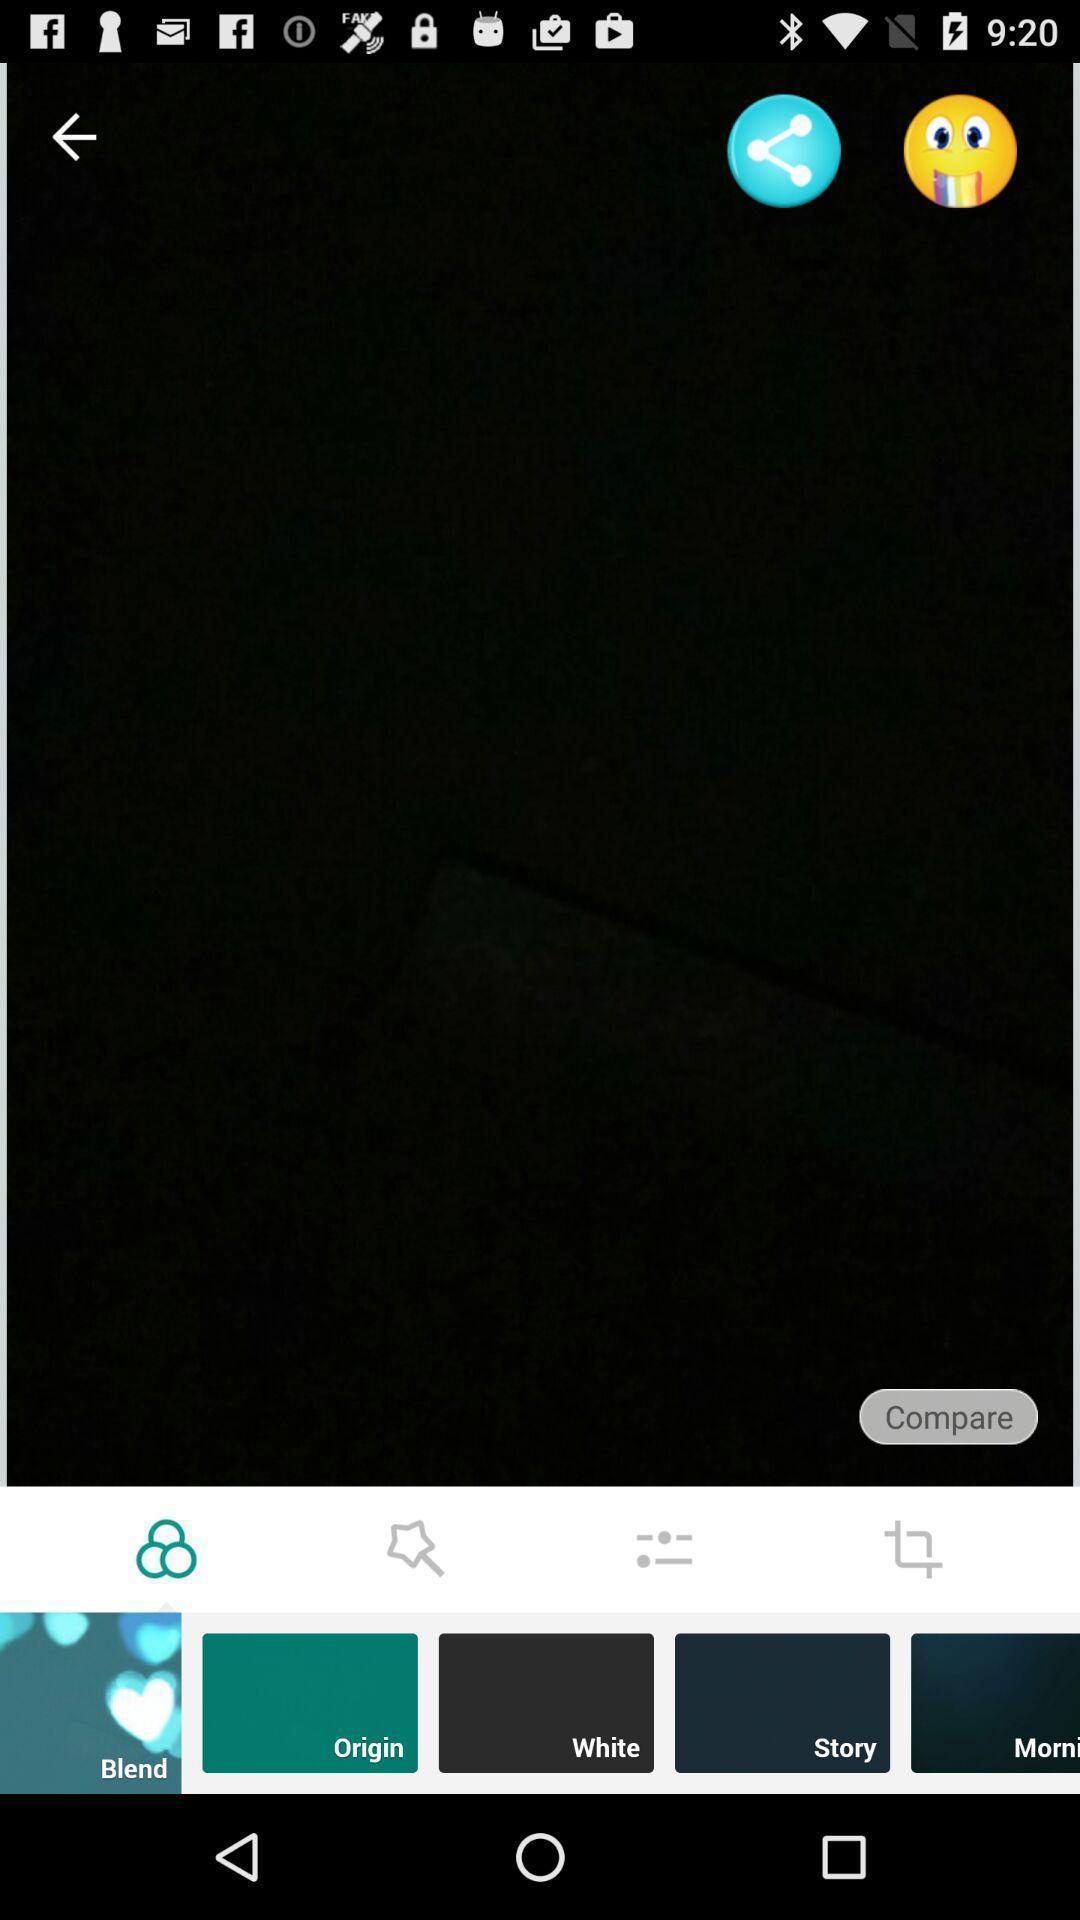Explain the elements present in this screenshot. Page showing the share options icon and emoji. 